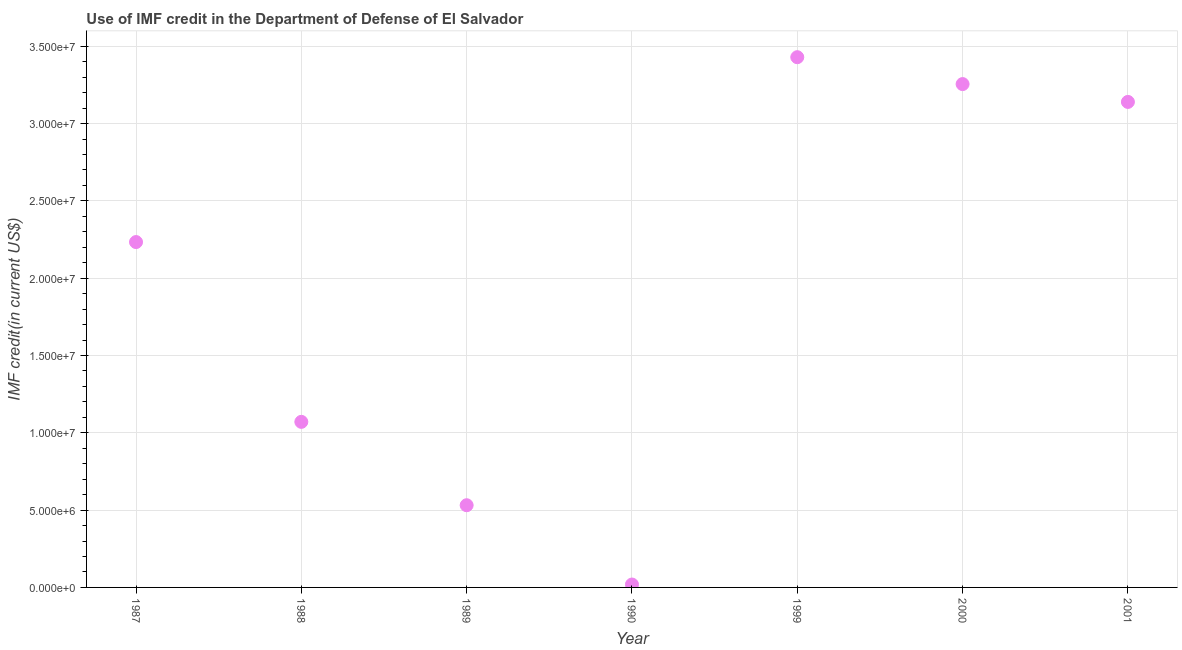What is the use of imf credit in dod in 1987?
Give a very brief answer. 2.23e+07. Across all years, what is the maximum use of imf credit in dod?
Make the answer very short. 3.43e+07. Across all years, what is the minimum use of imf credit in dod?
Your answer should be very brief. 1.88e+05. In which year was the use of imf credit in dod maximum?
Keep it short and to the point. 1999. In which year was the use of imf credit in dod minimum?
Offer a terse response. 1990. What is the sum of the use of imf credit in dod?
Your answer should be compact. 1.37e+08. What is the difference between the use of imf credit in dod in 1988 and 2000?
Offer a terse response. -2.18e+07. What is the average use of imf credit in dod per year?
Keep it short and to the point. 1.95e+07. What is the median use of imf credit in dod?
Give a very brief answer. 2.23e+07. Do a majority of the years between 1987 and 2000 (inclusive) have use of imf credit in dod greater than 10000000 US$?
Your answer should be compact. Yes. What is the ratio of the use of imf credit in dod in 1988 to that in 2000?
Offer a terse response. 0.33. Is the difference between the use of imf credit in dod in 1989 and 1999 greater than the difference between any two years?
Your answer should be very brief. No. What is the difference between the highest and the second highest use of imf credit in dod?
Ensure brevity in your answer.  1.74e+06. What is the difference between the highest and the lowest use of imf credit in dod?
Your answer should be very brief. 3.41e+07. Does the use of imf credit in dod monotonically increase over the years?
Make the answer very short. No. What is the difference between two consecutive major ticks on the Y-axis?
Offer a very short reply. 5.00e+06. Are the values on the major ticks of Y-axis written in scientific E-notation?
Offer a terse response. Yes. Does the graph contain grids?
Offer a terse response. Yes. What is the title of the graph?
Make the answer very short. Use of IMF credit in the Department of Defense of El Salvador. What is the label or title of the X-axis?
Your response must be concise. Year. What is the label or title of the Y-axis?
Provide a short and direct response. IMF credit(in current US$). What is the IMF credit(in current US$) in 1987?
Offer a terse response. 2.23e+07. What is the IMF credit(in current US$) in 1988?
Offer a very short reply. 1.07e+07. What is the IMF credit(in current US$) in 1989?
Ensure brevity in your answer.  5.32e+06. What is the IMF credit(in current US$) in 1990?
Your response must be concise. 1.88e+05. What is the IMF credit(in current US$) in 1999?
Your answer should be very brief. 3.43e+07. What is the IMF credit(in current US$) in 2000?
Offer a very short reply. 3.26e+07. What is the IMF credit(in current US$) in 2001?
Your response must be concise. 3.14e+07. What is the difference between the IMF credit(in current US$) in 1987 and 1988?
Your answer should be compact. 1.16e+07. What is the difference between the IMF credit(in current US$) in 1987 and 1989?
Ensure brevity in your answer.  1.70e+07. What is the difference between the IMF credit(in current US$) in 1987 and 1990?
Offer a very short reply. 2.21e+07. What is the difference between the IMF credit(in current US$) in 1987 and 1999?
Provide a succinct answer. -1.20e+07. What is the difference between the IMF credit(in current US$) in 1987 and 2000?
Your response must be concise. -1.02e+07. What is the difference between the IMF credit(in current US$) in 1987 and 2001?
Your answer should be compact. -9.06e+06. What is the difference between the IMF credit(in current US$) in 1988 and 1989?
Provide a short and direct response. 5.39e+06. What is the difference between the IMF credit(in current US$) in 1988 and 1990?
Give a very brief answer. 1.05e+07. What is the difference between the IMF credit(in current US$) in 1988 and 1999?
Your answer should be compact. -2.36e+07. What is the difference between the IMF credit(in current US$) in 1988 and 2000?
Offer a terse response. -2.18e+07. What is the difference between the IMF credit(in current US$) in 1988 and 2001?
Your response must be concise. -2.07e+07. What is the difference between the IMF credit(in current US$) in 1989 and 1990?
Offer a very short reply. 5.13e+06. What is the difference between the IMF credit(in current US$) in 1989 and 1999?
Offer a terse response. -2.90e+07. What is the difference between the IMF credit(in current US$) in 1989 and 2000?
Your answer should be very brief. -2.72e+07. What is the difference between the IMF credit(in current US$) in 1989 and 2001?
Give a very brief answer. -2.61e+07. What is the difference between the IMF credit(in current US$) in 1990 and 1999?
Provide a short and direct response. -3.41e+07. What is the difference between the IMF credit(in current US$) in 1990 and 2000?
Make the answer very short. -3.24e+07. What is the difference between the IMF credit(in current US$) in 1990 and 2001?
Keep it short and to the point. -3.12e+07. What is the difference between the IMF credit(in current US$) in 1999 and 2000?
Give a very brief answer. 1.74e+06. What is the difference between the IMF credit(in current US$) in 1999 and 2001?
Your response must be concise. 2.89e+06. What is the difference between the IMF credit(in current US$) in 2000 and 2001?
Give a very brief answer. 1.15e+06. What is the ratio of the IMF credit(in current US$) in 1987 to that in 1988?
Offer a very short reply. 2.09. What is the ratio of the IMF credit(in current US$) in 1987 to that in 1989?
Give a very brief answer. 4.2. What is the ratio of the IMF credit(in current US$) in 1987 to that in 1990?
Ensure brevity in your answer.  118.81. What is the ratio of the IMF credit(in current US$) in 1987 to that in 1999?
Your answer should be compact. 0.65. What is the ratio of the IMF credit(in current US$) in 1987 to that in 2000?
Provide a succinct answer. 0.69. What is the ratio of the IMF credit(in current US$) in 1987 to that in 2001?
Provide a short and direct response. 0.71. What is the ratio of the IMF credit(in current US$) in 1988 to that in 1989?
Your answer should be compact. 2.01. What is the ratio of the IMF credit(in current US$) in 1988 to that in 1990?
Your response must be concise. 56.96. What is the ratio of the IMF credit(in current US$) in 1988 to that in 1999?
Make the answer very short. 0.31. What is the ratio of the IMF credit(in current US$) in 1988 to that in 2000?
Offer a terse response. 0.33. What is the ratio of the IMF credit(in current US$) in 1988 to that in 2001?
Give a very brief answer. 0.34. What is the ratio of the IMF credit(in current US$) in 1989 to that in 1990?
Provide a short and direct response. 28.28. What is the ratio of the IMF credit(in current US$) in 1989 to that in 1999?
Provide a short and direct response. 0.15. What is the ratio of the IMF credit(in current US$) in 1989 to that in 2000?
Your answer should be very brief. 0.16. What is the ratio of the IMF credit(in current US$) in 1989 to that in 2001?
Provide a short and direct response. 0.17. What is the ratio of the IMF credit(in current US$) in 1990 to that in 1999?
Keep it short and to the point. 0.01. What is the ratio of the IMF credit(in current US$) in 1990 to that in 2000?
Offer a very short reply. 0.01. What is the ratio of the IMF credit(in current US$) in 1990 to that in 2001?
Provide a short and direct response. 0.01. What is the ratio of the IMF credit(in current US$) in 1999 to that in 2000?
Your response must be concise. 1.05. What is the ratio of the IMF credit(in current US$) in 1999 to that in 2001?
Your response must be concise. 1.09. What is the ratio of the IMF credit(in current US$) in 2000 to that in 2001?
Your answer should be compact. 1.04. 